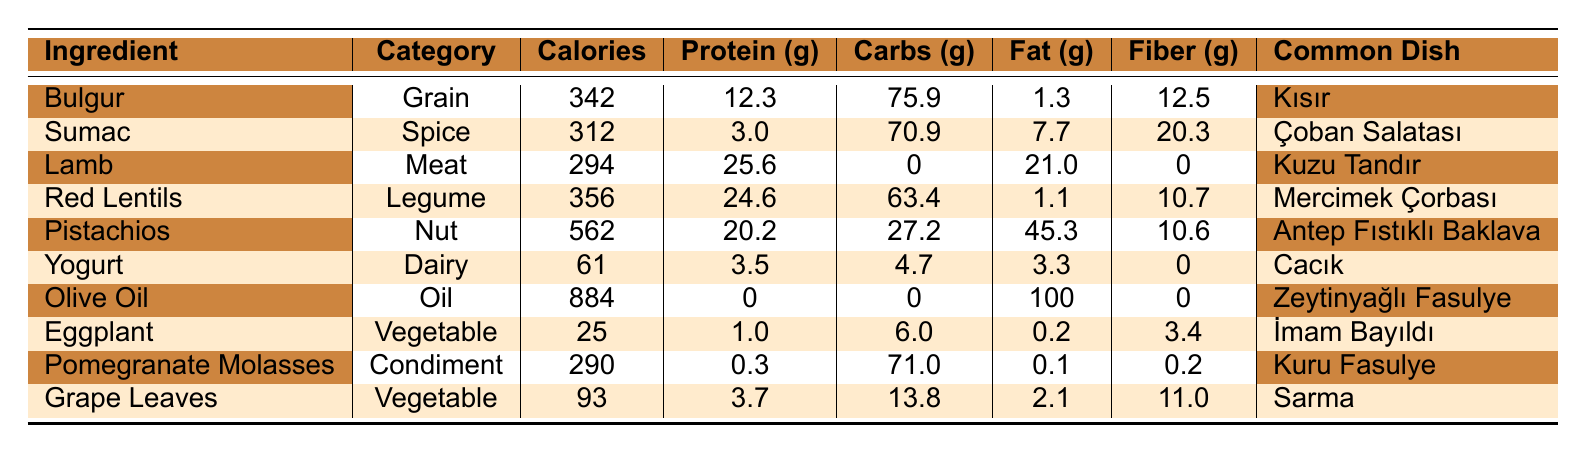What is the highest caloric ingredient in the table? Olive Oil has the highest calories at 884 calories per 100g, which is the highest value listed in the table.
Answer: Olive Oil Which ingredient contains the most protein per 100g? The ingredient with the highest protein content per 100g is Lamb, providing 25.6g of protein, according to the table.
Answer: Lamb What is the total carbohydrate content of Bulgur and Red Lentils? Bulgur contains 75.9g of carbs, and Red Lentils provide 63.4g. Adding these together gives 75.9 + 63.4 = 139.3g of carbohydrates.
Answer: 139.3g Is Yogurt a higher source of fiber than Eggplant? Yogurt has 0g of fiber while Eggplant has 3.4g of fiber. Thus, Eggplant has more fiber than Yogurt.
Answer: No What is the total fat content of Pistachios and Olive Oil combined? Pistachios contain 45.3g of fat and Olive Oil has 100g of fat. Adding these provides a total of 45.3 + 100 = 145.3g of fat.
Answer: 145.3g Which spice is used in Çoban Salatası and what is its fiber content? The spice used in Çoban Salatası is Sumac, and it contains 20.3g of fiber per 100g according to the table.
Answer: 20.3g If you consume 200g of Lamb, how much protein would you get? The protein content in Lamb is 25.6g per 100g, so for 200g it would be 25.6 * 2 = 51.2g of protein.
Answer: 51.2g Which contains more fiber, Grape Leaves or Sumac? Grape Leaves provide 11.0g of fiber while Sumac contains 20.3g. Comparing these values shows that Sumac has more fiber.
Answer: Yes What is the difference in calories between Red Lentils and Eggplant? Red Lentils have 356 calories and Eggplant has 25 calories. The difference is 356 - 25 = 331 calories.
Answer: 331 calories Which ingredient(s) have zero protein content? The ingredients with zero protein are Olive Oil and Pomegranate Molasses, as listed in the table.
Answer: Olive Oil and Pomegranate Molasses 